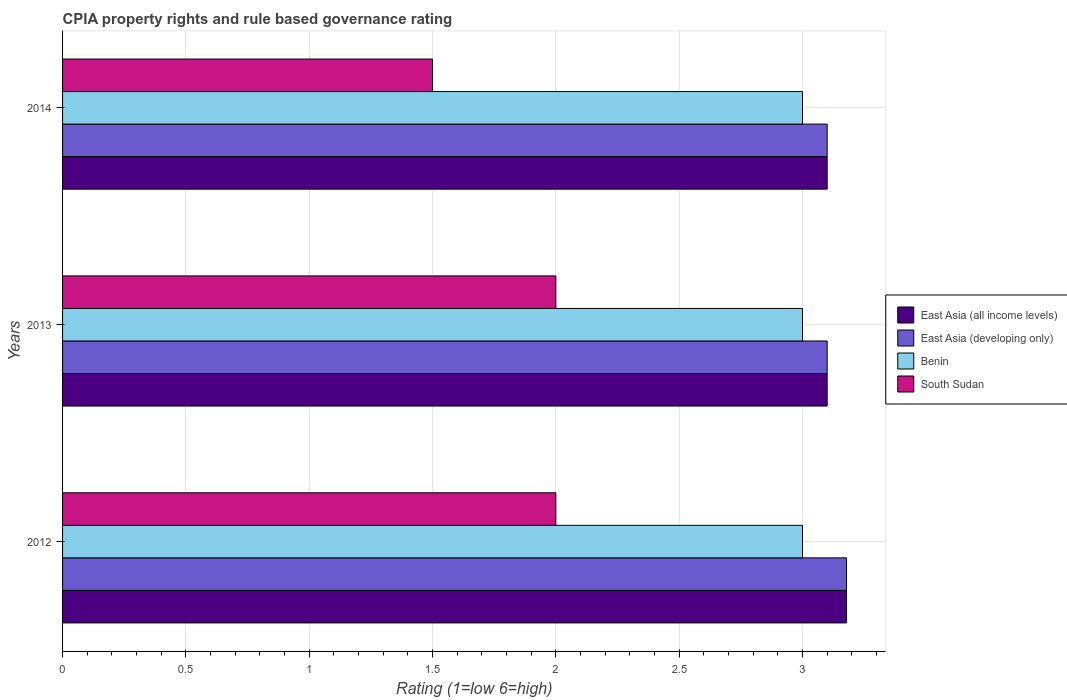How many different coloured bars are there?
Make the answer very short. 4. How many groups of bars are there?
Keep it short and to the point. 3. Are the number of bars per tick equal to the number of legend labels?
Your answer should be very brief. Yes. Are the number of bars on each tick of the Y-axis equal?
Ensure brevity in your answer.  Yes. How many bars are there on the 3rd tick from the bottom?
Offer a very short reply. 4. What is the label of the 2nd group of bars from the top?
Make the answer very short. 2013. In how many cases, is the number of bars for a given year not equal to the number of legend labels?
Ensure brevity in your answer.  0. Across all years, what is the maximum CPIA rating in Benin?
Your answer should be compact. 3. Across all years, what is the minimum CPIA rating in Benin?
Make the answer very short. 3. What is the total CPIA rating in East Asia (developing only) in the graph?
Ensure brevity in your answer.  9.38. What is the difference between the CPIA rating in Benin in 2012 and that in 2013?
Give a very brief answer. 0. What is the average CPIA rating in South Sudan per year?
Offer a very short reply. 1.83. In the year 2012, what is the difference between the CPIA rating in South Sudan and CPIA rating in East Asia (all income levels)?
Offer a very short reply. -1.18. In how many years, is the CPIA rating in South Sudan greater than 0.9 ?
Provide a short and direct response. 3. What is the ratio of the CPIA rating in East Asia (developing only) in 2012 to that in 2014?
Ensure brevity in your answer.  1.03. Is the difference between the CPIA rating in South Sudan in 2013 and 2014 greater than the difference between the CPIA rating in East Asia (all income levels) in 2013 and 2014?
Your answer should be very brief. Yes. What is the difference between the highest and the lowest CPIA rating in East Asia (developing only)?
Give a very brief answer. 0.08. In how many years, is the CPIA rating in South Sudan greater than the average CPIA rating in South Sudan taken over all years?
Offer a terse response. 2. Is the sum of the CPIA rating in East Asia (all income levels) in 2012 and 2014 greater than the maximum CPIA rating in Benin across all years?
Your answer should be very brief. Yes. What does the 2nd bar from the top in 2012 represents?
Offer a very short reply. Benin. What does the 3rd bar from the bottom in 2014 represents?
Provide a short and direct response. Benin. Are the values on the major ticks of X-axis written in scientific E-notation?
Your answer should be very brief. No. Does the graph contain grids?
Ensure brevity in your answer.  Yes. How many legend labels are there?
Your answer should be very brief. 4. How are the legend labels stacked?
Ensure brevity in your answer.  Vertical. What is the title of the graph?
Ensure brevity in your answer.  CPIA property rights and rule based governance rating. What is the Rating (1=low 6=high) of East Asia (all income levels) in 2012?
Ensure brevity in your answer.  3.18. What is the Rating (1=low 6=high) in East Asia (developing only) in 2012?
Offer a very short reply. 3.18. What is the Rating (1=low 6=high) of South Sudan in 2012?
Keep it short and to the point. 2. What is the Rating (1=low 6=high) in East Asia (developing only) in 2013?
Keep it short and to the point. 3.1. What is the Rating (1=low 6=high) in South Sudan in 2013?
Your answer should be compact. 2. What is the Rating (1=low 6=high) of Benin in 2014?
Keep it short and to the point. 3. What is the Rating (1=low 6=high) in South Sudan in 2014?
Provide a succinct answer. 1.5. Across all years, what is the maximum Rating (1=low 6=high) in East Asia (all income levels)?
Your answer should be very brief. 3.18. Across all years, what is the maximum Rating (1=low 6=high) in East Asia (developing only)?
Keep it short and to the point. 3.18. Across all years, what is the minimum Rating (1=low 6=high) of Benin?
Your answer should be very brief. 3. What is the total Rating (1=low 6=high) in East Asia (all income levels) in the graph?
Keep it short and to the point. 9.38. What is the total Rating (1=low 6=high) in East Asia (developing only) in the graph?
Your answer should be very brief. 9.38. What is the difference between the Rating (1=low 6=high) in East Asia (all income levels) in 2012 and that in 2013?
Provide a succinct answer. 0.08. What is the difference between the Rating (1=low 6=high) in East Asia (developing only) in 2012 and that in 2013?
Your answer should be compact. 0.08. What is the difference between the Rating (1=low 6=high) in Benin in 2012 and that in 2013?
Provide a succinct answer. 0. What is the difference between the Rating (1=low 6=high) of South Sudan in 2012 and that in 2013?
Your response must be concise. 0. What is the difference between the Rating (1=low 6=high) of East Asia (all income levels) in 2012 and that in 2014?
Provide a succinct answer. 0.08. What is the difference between the Rating (1=low 6=high) in East Asia (developing only) in 2012 and that in 2014?
Make the answer very short. 0.08. What is the difference between the Rating (1=low 6=high) in Benin in 2012 and that in 2014?
Make the answer very short. 0. What is the difference between the Rating (1=low 6=high) in South Sudan in 2012 and that in 2014?
Your answer should be compact. 0.5. What is the difference between the Rating (1=low 6=high) of East Asia (developing only) in 2013 and that in 2014?
Make the answer very short. 0. What is the difference between the Rating (1=low 6=high) of South Sudan in 2013 and that in 2014?
Provide a short and direct response. 0.5. What is the difference between the Rating (1=low 6=high) of East Asia (all income levels) in 2012 and the Rating (1=low 6=high) of East Asia (developing only) in 2013?
Keep it short and to the point. 0.08. What is the difference between the Rating (1=low 6=high) in East Asia (all income levels) in 2012 and the Rating (1=low 6=high) in Benin in 2013?
Provide a short and direct response. 0.18. What is the difference between the Rating (1=low 6=high) in East Asia (all income levels) in 2012 and the Rating (1=low 6=high) in South Sudan in 2013?
Keep it short and to the point. 1.18. What is the difference between the Rating (1=low 6=high) in East Asia (developing only) in 2012 and the Rating (1=low 6=high) in Benin in 2013?
Your answer should be compact. 0.18. What is the difference between the Rating (1=low 6=high) of East Asia (developing only) in 2012 and the Rating (1=low 6=high) of South Sudan in 2013?
Give a very brief answer. 1.18. What is the difference between the Rating (1=low 6=high) in Benin in 2012 and the Rating (1=low 6=high) in South Sudan in 2013?
Provide a succinct answer. 1. What is the difference between the Rating (1=low 6=high) in East Asia (all income levels) in 2012 and the Rating (1=low 6=high) in East Asia (developing only) in 2014?
Make the answer very short. 0.08. What is the difference between the Rating (1=low 6=high) of East Asia (all income levels) in 2012 and the Rating (1=low 6=high) of Benin in 2014?
Ensure brevity in your answer.  0.18. What is the difference between the Rating (1=low 6=high) in East Asia (all income levels) in 2012 and the Rating (1=low 6=high) in South Sudan in 2014?
Your answer should be compact. 1.68. What is the difference between the Rating (1=low 6=high) of East Asia (developing only) in 2012 and the Rating (1=low 6=high) of Benin in 2014?
Offer a terse response. 0.18. What is the difference between the Rating (1=low 6=high) of East Asia (developing only) in 2012 and the Rating (1=low 6=high) of South Sudan in 2014?
Make the answer very short. 1.68. What is the difference between the Rating (1=low 6=high) of Benin in 2012 and the Rating (1=low 6=high) of South Sudan in 2014?
Your answer should be compact. 1.5. What is the difference between the Rating (1=low 6=high) of East Asia (developing only) in 2013 and the Rating (1=low 6=high) of Benin in 2014?
Offer a terse response. 0.1. What is the average Rating (1=low 6=high) in East Asia (all income levels) per year?
Keep it short and to the point. 3.13. What is the average Rating (1=low 6=high) of East Asia (developing only) per year?
Provide a short and direct response. 3.13. What is the average Rating (1=low 6=high) of South Sudan per year?
Give a very brief answer. 1.83. In the year 2012, what is the difference between the Rating (1=low 6=high) of East Asia (all income levels) and Rating (1=low 6=high) of Benin?
Your response must be concise. 0.18. In the year 2012, what is the difference between the Rating (1=low 6=high) in East Asia (all income levels) and Rating (1=low 6=high) in South Sudan?
Your answer should be compact. 1.18. In the year 2012, what is the difference between the Rating (1=low 6=high) of East Asia (developing only) and Rating (1=low 6=high) of Benin?
Keep it short and to the point. 0.18. In the year 2012, what is the difference between the Rating (1=low 6=high) in East Asia (developing only) and Rating (1=low 6=high) in South Sudan?
Provide a short and direct response. 1.18. In the year 2012, what is the difference between the Rating (1=low 6=high) in Benin and Rating (1=low 6=high) in South Sudan?
Give a very brief answer. 1. In the year 2013, what is the difference between the Rating (1=low 6=high) of East Asia (all income levels) and Rating (1=low 6=high) of Benin?
Ensure brevity in your answer.  0.1. In the year 2013, what is the difference between the Rating (1=low 6=high) of East Asia (all income levels) and Rating (1=low 6=high) of South Sudan?
Offer a terse response. 1.1. In the year 2013, what is the difference between the Rating (1=low 6=high) in Benin and Rating (1=low 6=high) in South Sudan?
Provide a short and direct response. 1. In the year 2014, what is the difference between the Rating (1=low 6=high) of East Asia (all income levels) and Rating (1=low 6=high) of South Sudan?
Offer a terse response. 1.6. What is the ratio of the Rating (1=low 6=high) in East Asia (all income levels) in 2012 to that in 2013?
Your answer should be very brief. 1.03. What is the ratio of the Rating (1=low 6=high) in East Asia (developing only) in 2012 to that in 2013?
Offer a very short reply. 1.03. What is the ratio of the Rating (1=low 6=high) of East Asia (all income levels) in 2012 to that in 2014?
Provide a short and direct response. 1.03. What is the ratio of the Rating (1=low 6=high) of East Asia (developing only) in 2012 to that in 2014?
Your answer should be very brief. 1.03. What is the ratio of the Rating (1=low 6=high) in Benin in 2012 to that in 2014?
Make the answer very short. 1. What is the ratio of the Rating (1=low 6=high) of East Asia (all income levels) in 2013 to that in 2014?
Your answer should be compact. 1. What is the difference between the highest and the second highest Rating (1=low 6=high) in East Asia (all income levels)?
Your answer should be very brief. 0.08. What is the difference between the highest and the second highest Rating (1=low 6=high) in East Asia (developing only)?
Make the answer very short. 0.08. What is the difference between the highest and the second highest Rating (1=low 6=high) of Benin?
Offer a terse response. 0. What is the difference between the highest and the lowest Rating (1=low 6=high) of East Asia (all income levels)?
Your answer should be very brief. 0.08. What is the difference between the highest and the lowest Rating (1=low 6=high) in East Asia (developing only)?
Your answer should be very brief. 0.08. What is the difference between the highest and the lowest Rating (1=low 6=high) in Benin?
Keep it short and to the point. 0. What is the difference between the highest and the lowest Rating (1=low 6=high) in South Sudan?
Keep it short and to the point. 0.5. 